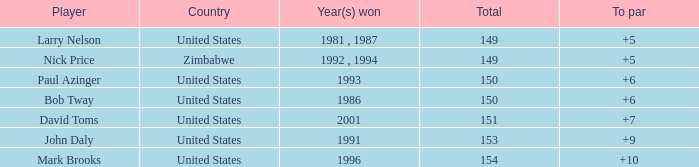Which player won in 1993? Paul Azinger. 